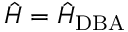Convert formula to latex. <formula><loc_0><loc_0><loc_500><loc_500>{ \hat { H } } = { \hat { H } } _ { D B A }</formula> 